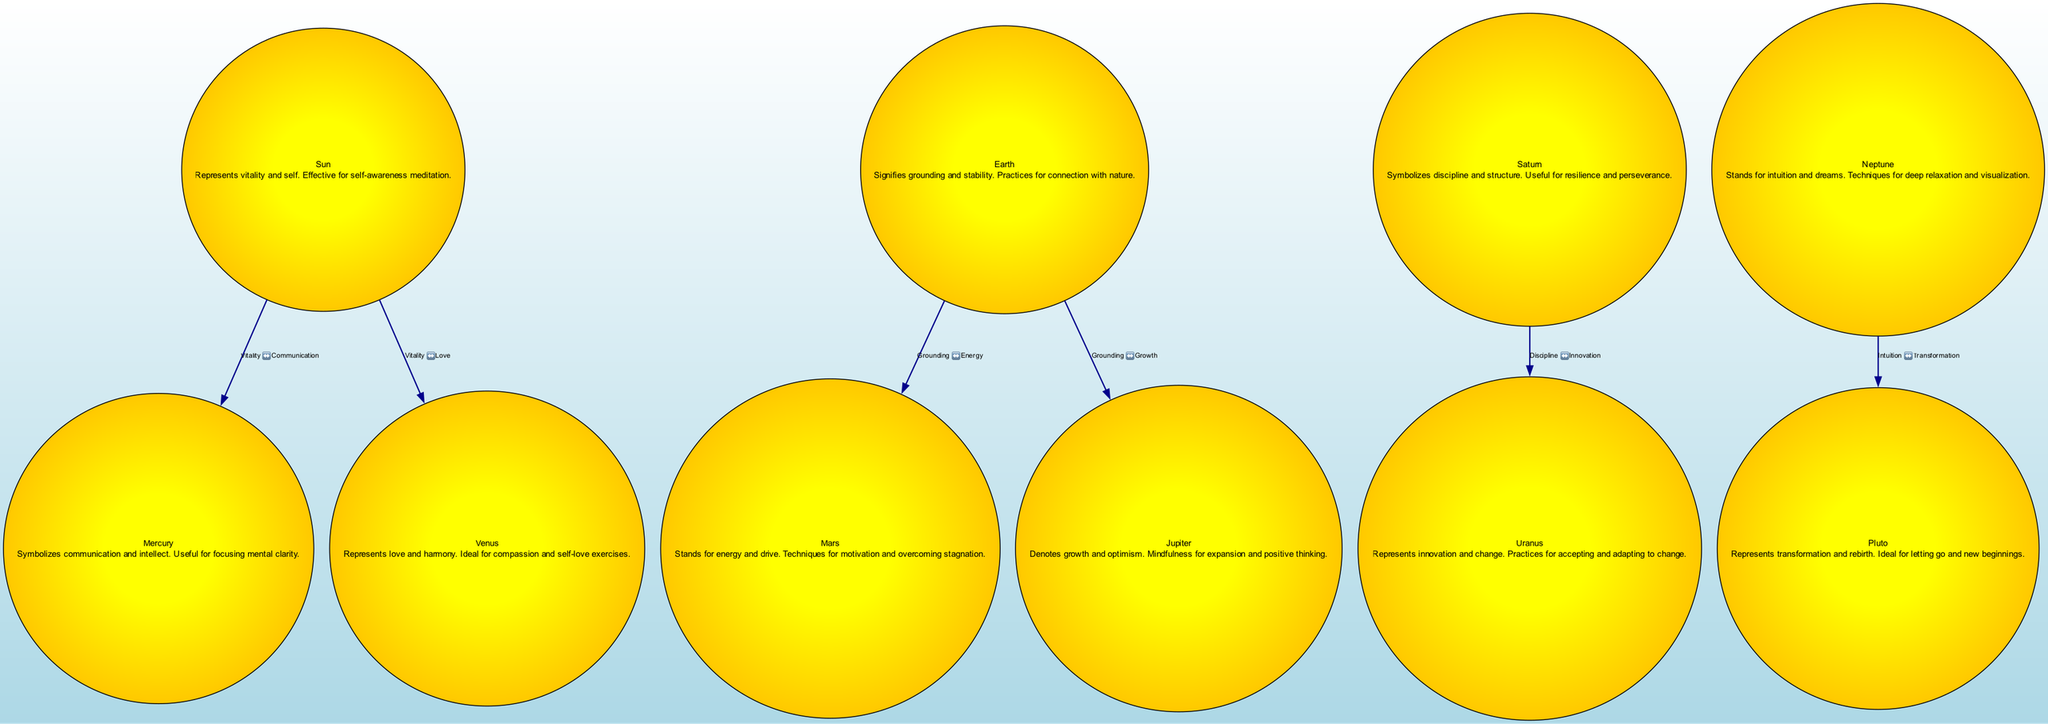What planet represents love and harmony? In the diagram, Venus is the planet that is specifically described as representing love and harmony, making it ideal for compassion and self-love exercises.
Answer: Venus How many nodes are represented in the diagram? By counting each unique entry listed under the "nodes" section of the data, we find a total of 10 nodes depicting different planets and their mindfulness symbolism.
Answer: 10 What does Neptune signify in this diagram? The description for Neptune in the diagram indicates that it stands for intuition and dreams, which suggests its association with techniques for deep relaxation and visualization.
Answer: Intuition and dreams Which two planets are connected by the edge labeled "Discipline ↔️ Innovation"? The edge labeled "Discipline ↔️ Innovation" shows a direct connection between Saturn and Uranus. Therefore, these two planets are the ones connected by this edge.
Answer: Saturn and Uranus What is the primary symbolism associated with Jupiter? According to the diagram, Jupiter denotes growth and optimism, highlighting its role in mindfulness practices for expansion and positive thinking.
Answer: Growth and optimism Which planet's description emphasizes techniques for letting go and new beginnings? The description for Pluto specifically articulates its symbolism of transformation and rebirth, indicating its association with techniques for letting go and new beginnings.
Answer: Pluto How does the diagram connect Grounding and Growth? Grounding is associated with Earth, while Growth is linked to Jupiter. The diagram indicates a connection between these two concepts through a direct edge from Earth to Jupiter.
Answer: Earth to Jupiter What is the focus of Mercury's symbolism according to the diagram? The diagram specifies that Mercury symbolizes communication and intellect, making it a focal point for practices aimed at enhancing mental clarity.
Answer: Communication and intellect What relationship do Sun and Venus have as per the diagram? The diagram explicitly shows an edge between Sun and Venus labeled "Vitality ↔️ Love," which indicates a connection that suggests from vitality to love and vice versa.
Answer: Vitality to Love 